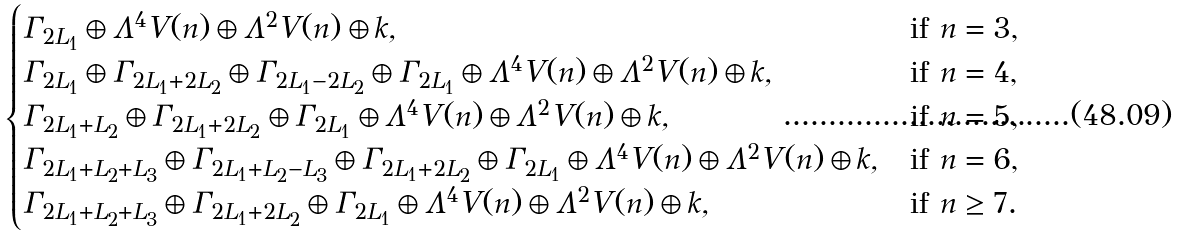Convert formula to latex. <formula><loc_0><loc_0><loc_500><loc_500>\begin{cases} \Gamma _ { 2 L _ { 1 } } \oplus \Lambda ^ { 4 } V ( n ) \oplus \Lambda ^ { 2 } V ( n ) \oplus k , & \text {if $n=3$,} \\ \Gamma _ { 2 L _ { 1 } } \oplus \Gamma _ { 2 L _ { 1 } + 2 L _ { 2 } } \oplus \Gamma _ { 2 L _ { 1 } - 2 L _ { 2 } } \oplus \Gamma _ { 2 L _ { 1 } } \oplus \Lambda ^ { 4 } V ( n ) \oplus \Lambda ^ { 2 } V ( n ) \oplus k , & \text {if $n=4$,} \\ \Gamma _ { 2 L _ { 1 } + L _ { 2 } } \oplus \Gamma _ { 2 L _ { 1 } + 2 L _ { 2 } } \oplus \Gamma _ { 2 L _ { 1 } } \oplus \Lambda ^ { 4 } V ( n ) \oplus \Lambda ^ { 2 } V ( n ) \oplus k , & \text {if $n=5$,} \\ \Gamma _ { 2 L _ { 1 } + L _ { 2 } + L _ { 3 } } \oplus \Gamma _ { 2 L _ { 1 } + L _ { 2 } - L _ { 3 } } \oplus \Gamma _ { 2 L _ { 1 } + 2 L _ { 2 } } \oplus \Gamma _ { 2 L _ { 1 } } \oplus \Lambda ^ { 4 } V ( n ) \oplus \Lambda ^ { 2 } V ( n ) \oplus k , & \text {if $n=6$,} \\ \Gamma _ { 2 L _ { 1 } + L _ { 2 } + L _ { 3 } } \oplus \Gamma _ { 2 L _ { 1 } + 2 L _ { 2 } } \oplus \Gamma _ { 2 L _ { 1 } } \oplus \Lambda ^ { 4 } V ( n ) \oplus \Lambda ^ { 2 } V ( n ) \oplus k , & \text {if $n \geq 7$.} \end{cases}</formula> 